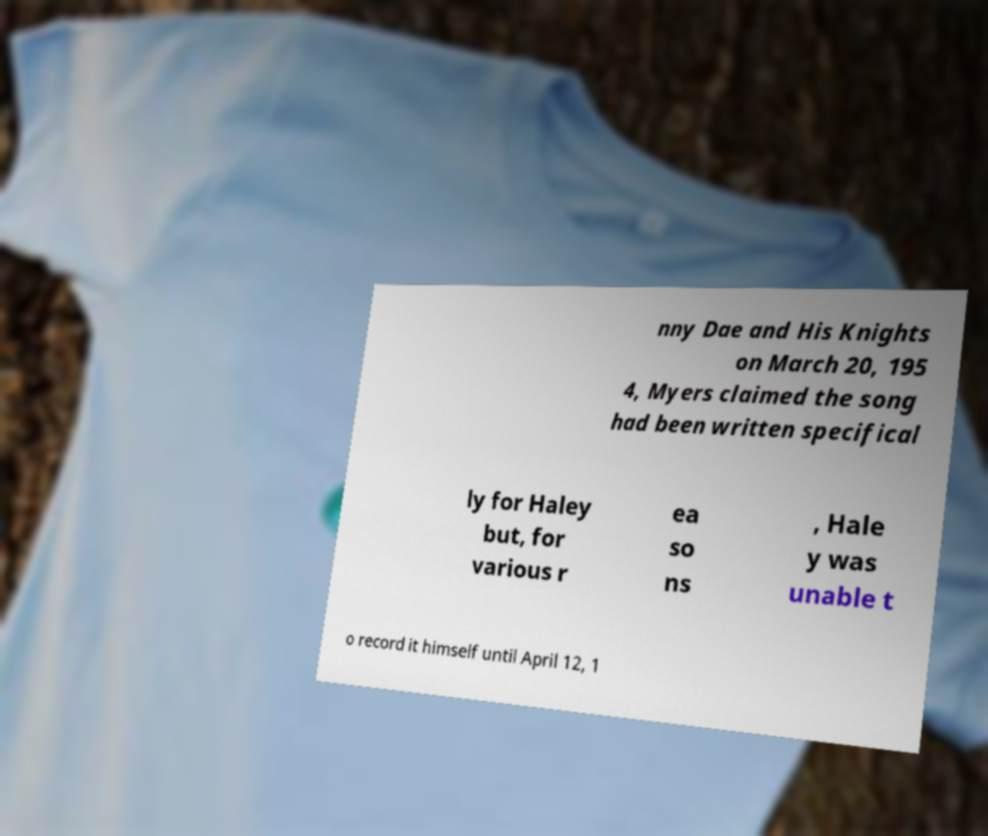Please read and relay the text visible in this image. What does it say? nny Dae and His Knights on March 20, 195 4, Myers claimed the song had been written specifical ly for Haley but, for various r ea so ns , Hale y was unable t o record it himself until April 12, 1 